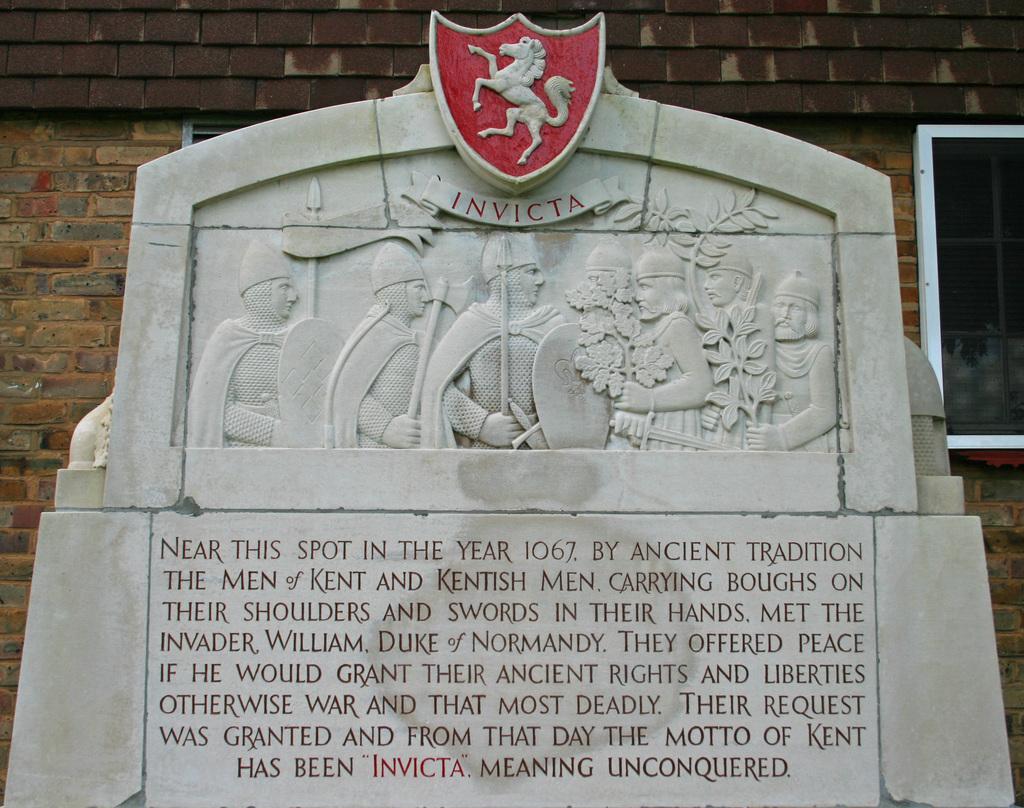Can you describe this image briefly? There are sculptures and inscriptions on a gray color slab. In the background, there is a brick wall. 